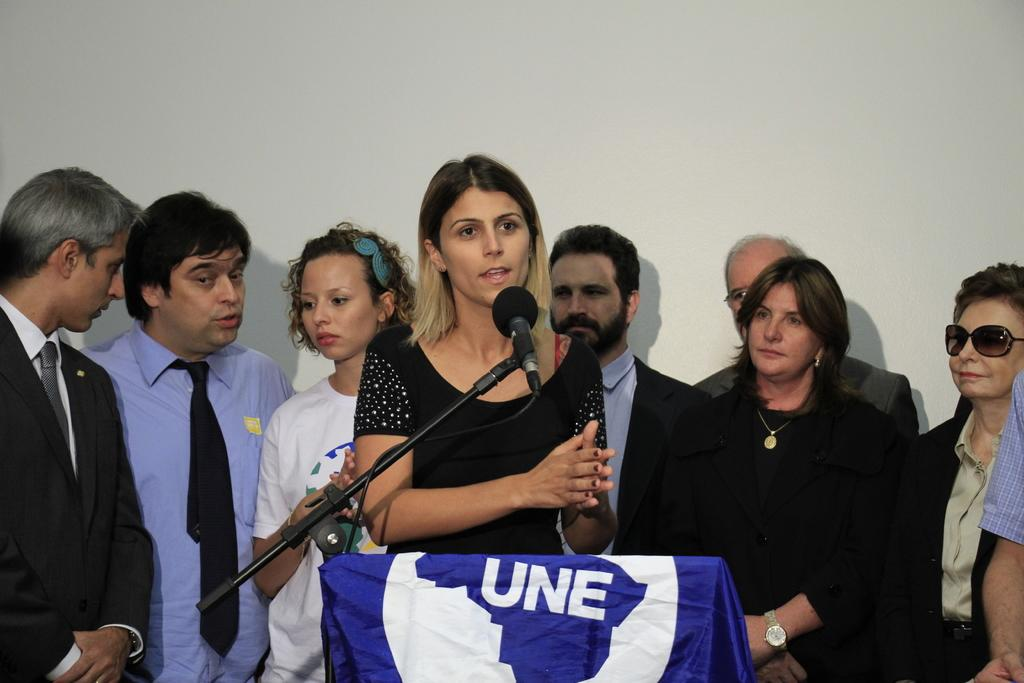How many people are in the image? There are people standing in the image. What is the person at the lectern doing? One person is at a lectern. What is attached to the lectern? A mic is attached to the lectern. What is covering the mic? The mic is covered with a cloth. What type of leather is visible on the person's toe in the image? There is no leather or toe visible in the image; the focus is on the people, the lectern, and the mic. 